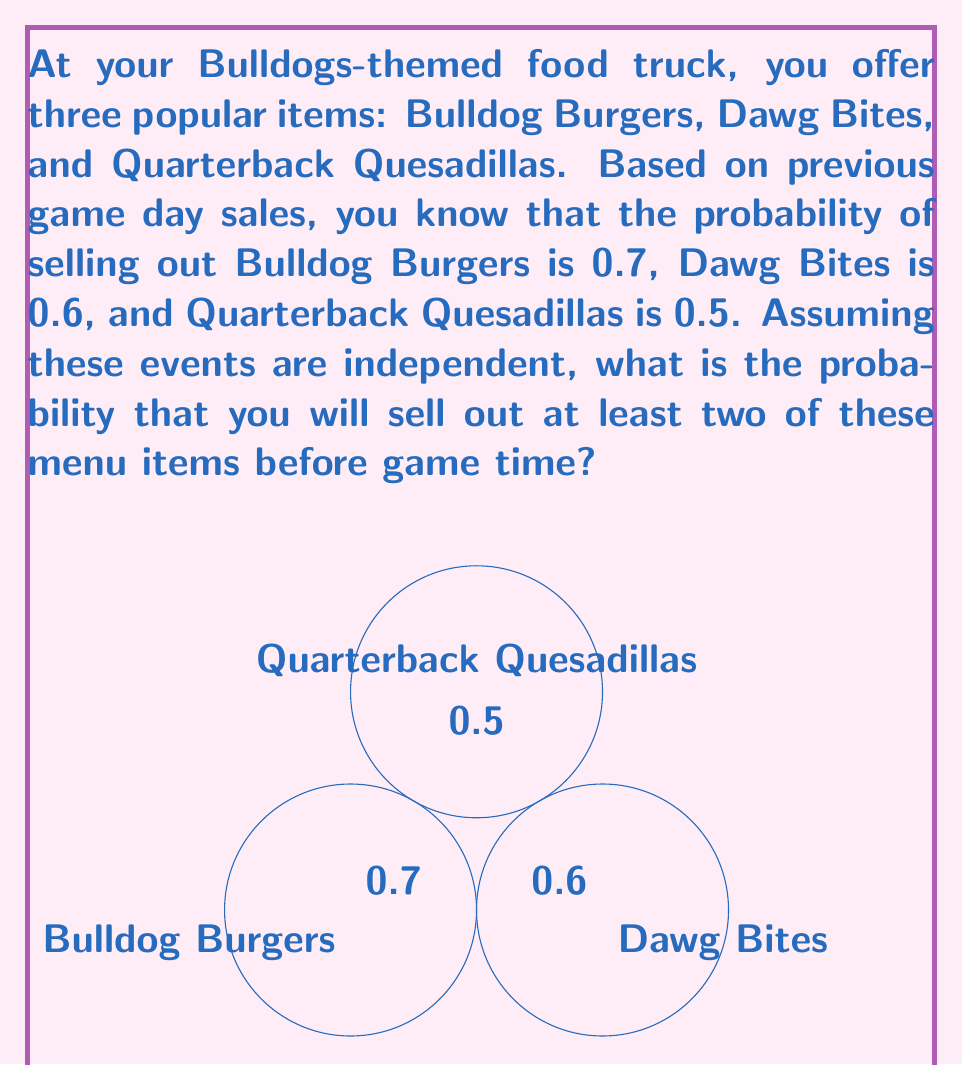Show me your answer to this math problem. Let's approach this step-by-step:

1) First, let's define our events:
   A: Selling out Bulldog Burgers
   B: Selling out Dawg Bites
   C: Selling out Quarterback Quesadillas

2) We're looking for the probability of selling out at least two items. This is equivalent to the probability of selling out all three items, or any two items.

3) Let's start by calculating the probability of not selling out each item:
   P(not A) = 1 - 0.7 = 0.3
   P(not B) = 1 - 0.6 = 0.4
   P(not C) = 1 - 0.5 = 0.5

4) The probability of selling out at least two items is the complement of the probability of selling out one or fewer items. So, we'll calculate the probability of selling out one or fewer items and subtract it from 1.

5) Probability of selling out no items:
   P(not A and not B and not C) = 0.3 × 0.4 × 0.5 = 0.06

6) Probability of selling out exactly one item:
   P(A and not B and not C) = 0.7 × 0.4 × 0.5 = 0.14
   P(not A and B and not C) = 0.3 × 0.6 × 0.5 = 0.09
   P(not A and not B and C) = 0.3 × 0.4 × 0.5 = 0.06

7) Total probability of selling out one or fewer items:
   0.06 + 0.14 + 0.09 + 0.06 = 0.35

8) Therefore, the probability of selling out at least two items is:
   1 - 0.35 = 0.65

Thus, there is a 65% chance of selling out at least two menu items before game time.
Answer: 0.65 